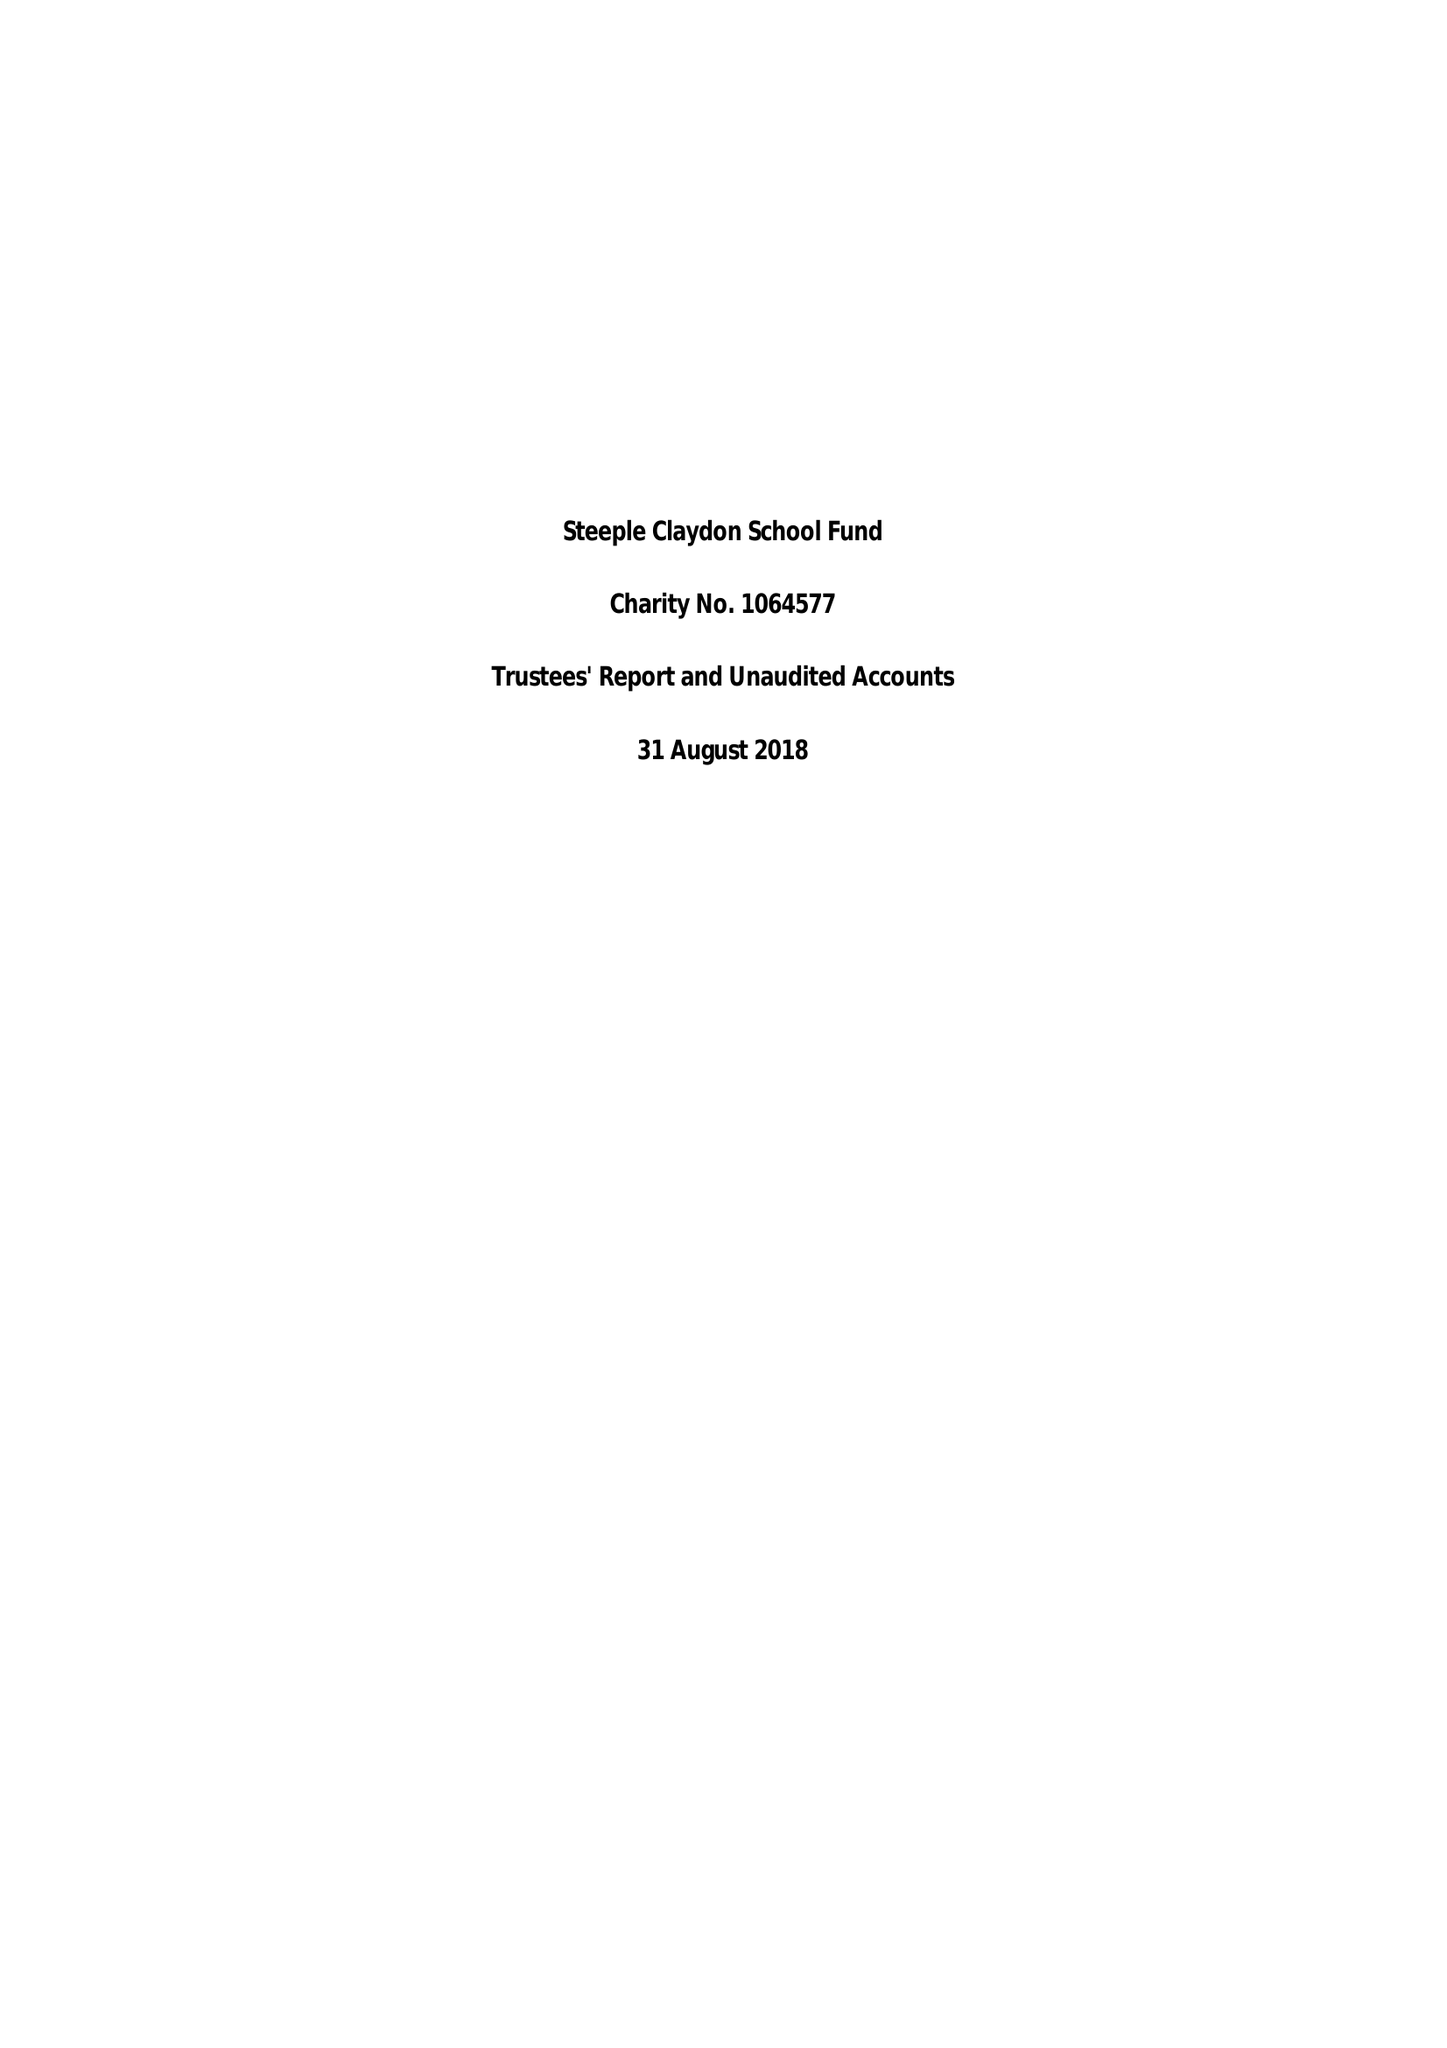What is the value for the income_annually_in_british_pounds?
Answer the question using a single word or phrase. 56757.00 